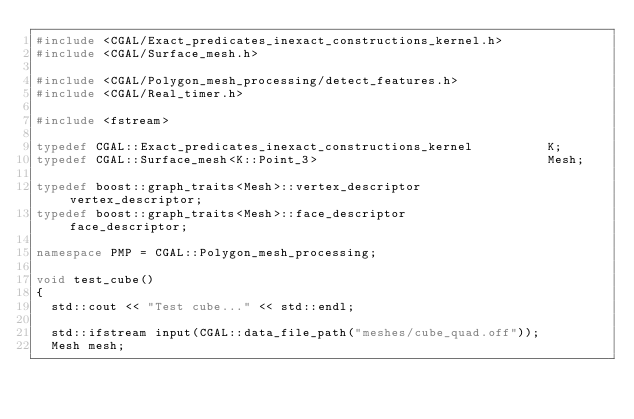<code> <loc_0><loc_0><loc_500><loc_500><_C++_>#include <CGAL/Exact_predicates_inexact_constructions_kernel.h>
#include <CGAL/Surface_mesh.h>

#include <CGAL/Polygon_mesh_processing/detect_features.h>
#include <CGAL/Real_timer.h>

#include <fstream>

typedef CGAL::Exact_predicates_inexact_constructions_kernel          K;
typedef CGAL::Surface_mesh<K::Point_3>                               Mesh;

typedef boost::graph_traits<Mesh>::vertex_descriptor                 vertex_descriptor;
typedef boost::graph_traits<Mesh>::face_descriptor                   face_descriptor;

namespace PMP = CGAL::Polygon_mesh_processing;

void test_cube()
{
  std::cout << "Test cube..." << std::endl;

  std::ifstream input(CGAL::data_file_path("meshes/cube_quad.off"));
  Mesh mesh;</code> 